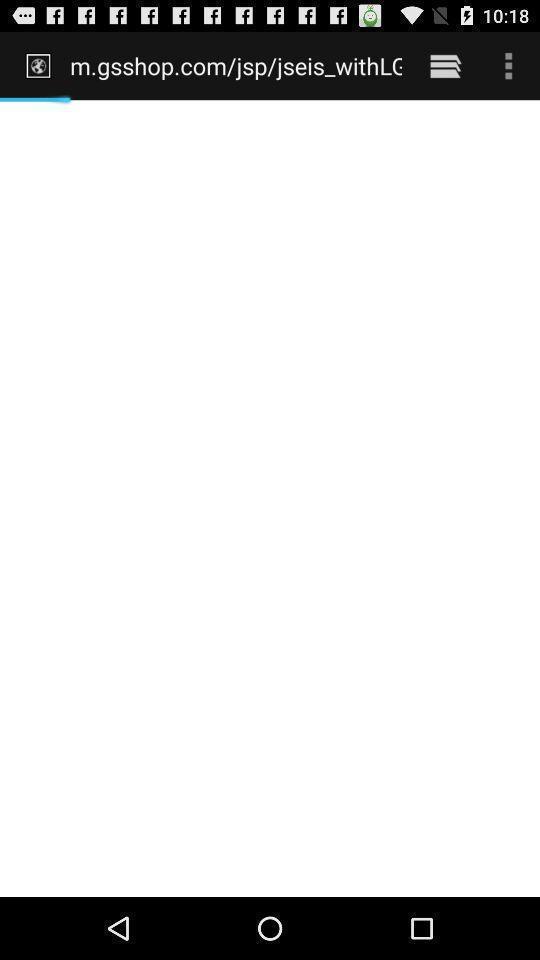Please provide a description for this image. Screen showing web address. 